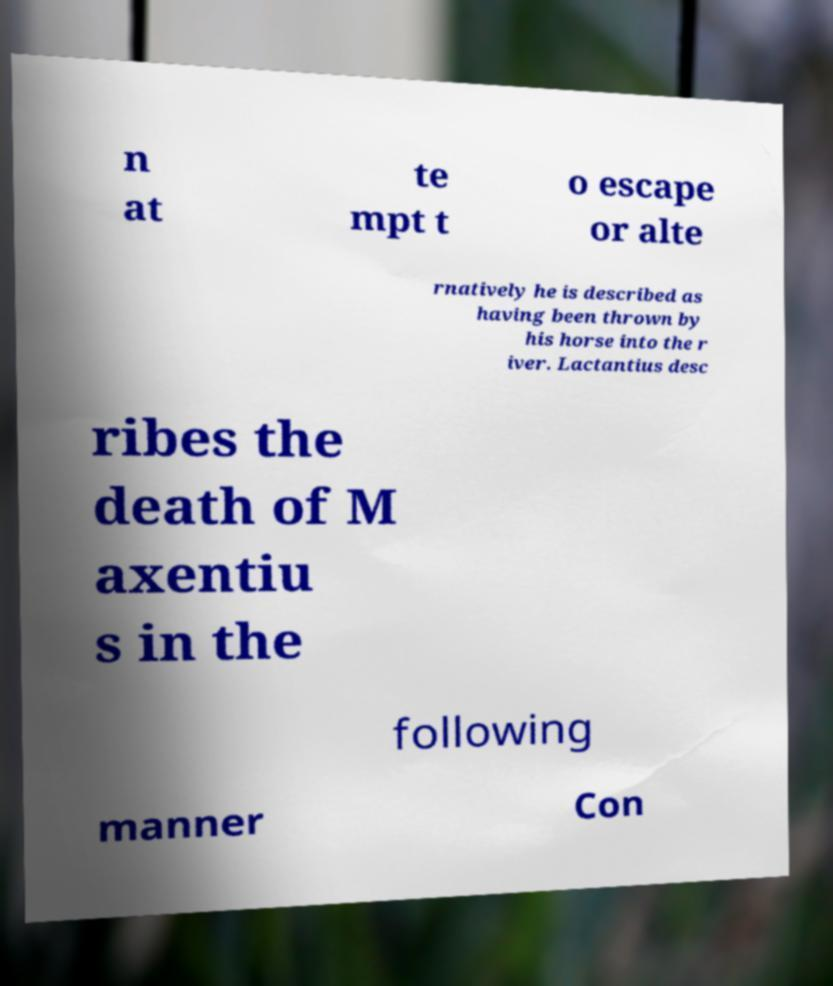Could you extract and type out the text from this image? n at te mpt t o escape or alte rnatively he is described as having been thrown by his horse into the r iver. Lactantius desc ribes the death of M axentiu s in the following manner Con 